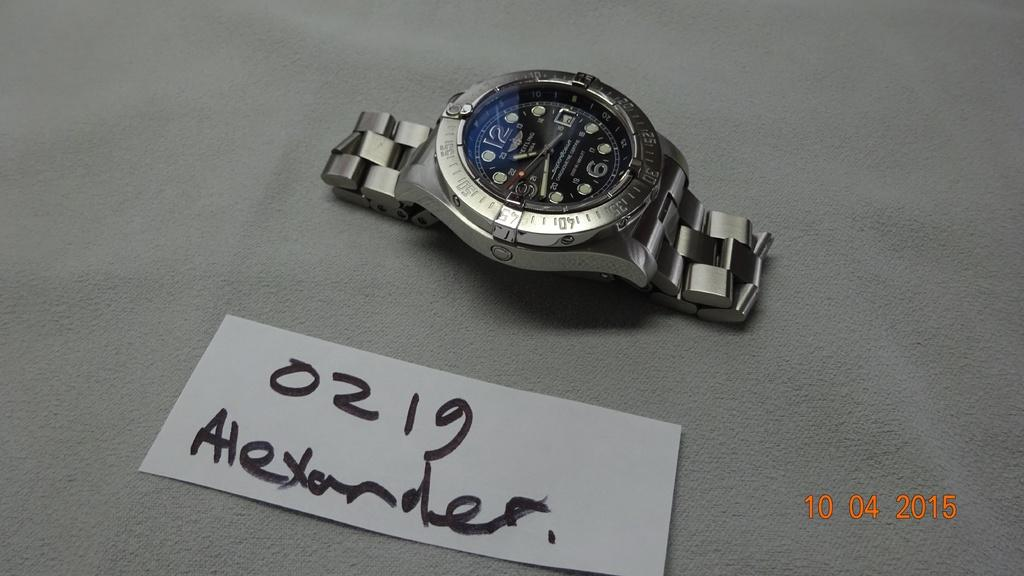Provide a one-sentence caption for the provided image. the watch is laying by a tag that says 0219 Alexander. 